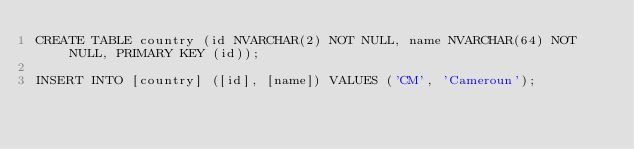Convert code to text. <code><loc_0><loc_0><loc_500><loc_500><_SQL_>CREATE TABLE country (id NVARCHAR(2) NOT NULL, name NVARCHAR(64) NOT NULL, PRIMARY KEY (id));

INSERT INTO [country] ([id], [name]) VALUES ('CM', 'Cameroun');
</code> 